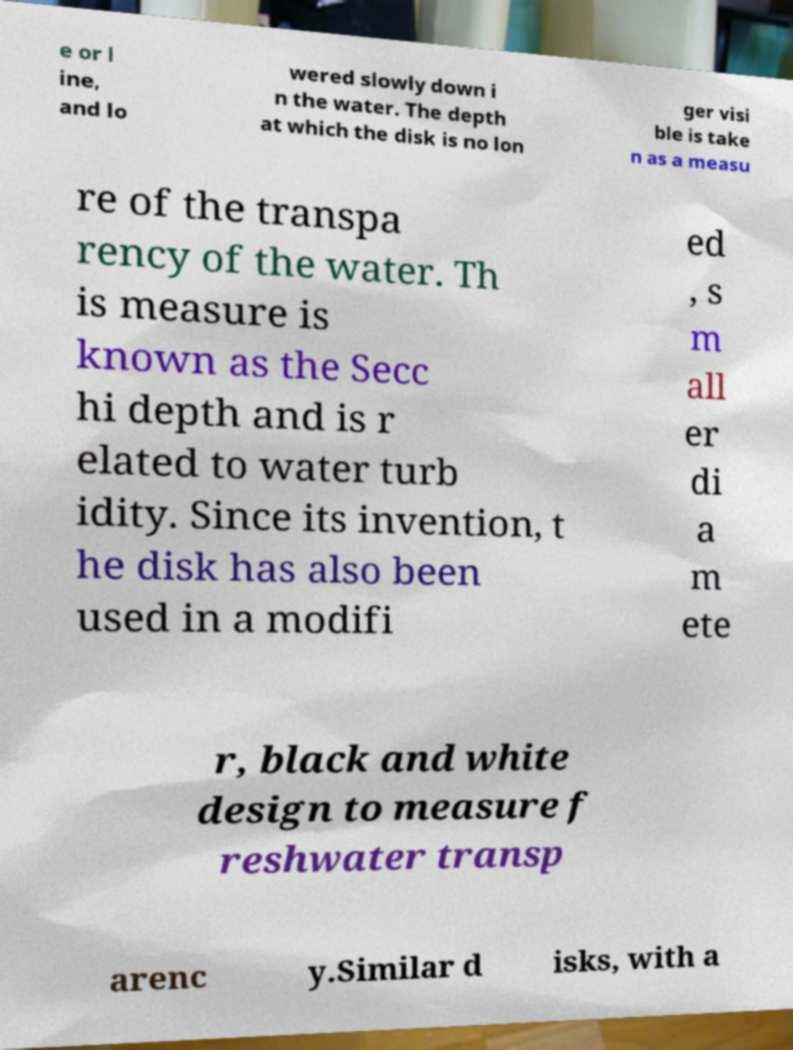I need the written content from this picture converted into text. Can you do that? e or l ine, and lo wered slowly down i n the water. The depth at which the disk is no lon ger visi ble is take n as a measu re of the transpa rency of the water. Th is measure is known as the Secc hi depth and is r elated to water turb idity. Since its invention, t he disk has also been used in a modifi ed , s m all er di a m ete r, black and white design to measure f reshwater transp arenc y.Similar d isks, with a 